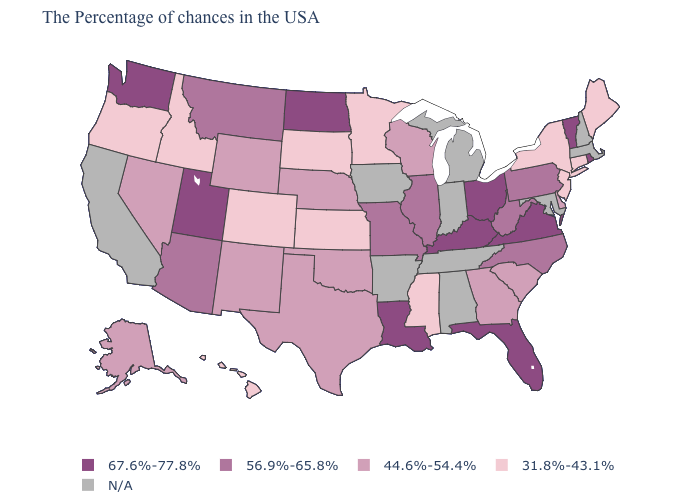Among the states that border Iowa , does Illinois have the lowest value?
Write a very short answer. No. Which states hav the highest value in the West?
Be succinct. Utah, Washington. Does Hawaii have the lowest value in the USA?
Concise answer only. Yes. What is the lowest value in the USA?
Answer briefly. 31.8%-43.1%. Name the states that have a value in the range 56.9%-65.8%?
Short answer required. Pennsylvania, North Carolina, West Virginia, Illinois, Missouri, Montana, Arizona. Name the states that have a value in the range N/A?
Quick response, please. Massachusetts, New Hampshire, Maryland, Michigan, Indiana, Alabama, Tennessee, Arkansas, Iowa, California. Among the states that border Massachusetts , which have the highest value?
Keep it brief. Rhode Island, Vermont. Which states have the lowest value in the South?
Give a very brief answer. Mississippi. Among the states that border Washington , which have the highest value?
Quick response, please. Idaho, Oregon. Does South Dakota have the highest value in the USA?
Write a very short answer. No. Which states have the lowest value in the USA?
Quick response, please. Maine, Connecticut, New York, New Jersey, Mississippi, Minnesota, Kansas, South Dakota, Colorado, Idaho, Oregon, Hawaii. Name the states that have a value in the range N/A?
Answer briefly. Massachusetts, New Hampshire, Maryland, Michigan, Indiana, Alabama, Tennessee, Arkansas, Iowa, California. What is the value of California?
Keep it brief. N/A. 